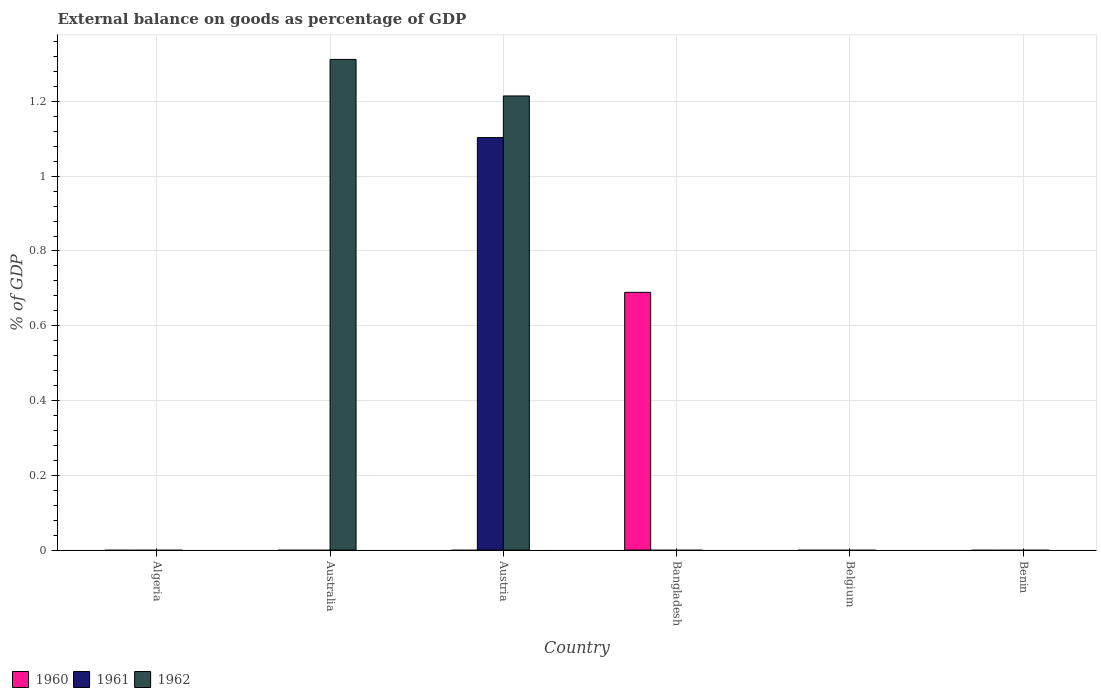Are the number of bars per tick equal to the number of legend labels?
Ensure brevity in your answer.  No. How many bars are there on the 6th tick from the right?
Offer a terse response. 0. What is the label of the 6th group of bars from the left?
Offer a terse response. Benin. Across all countries, what is the maximum external balance on goods as percentage of GDP in 1962?
Give a very brief answer. 1.31. Across all countries, what is the minimum external balance on goods as percentage of GDP in 1962?
Your response must be concise. 0. What is the total external balance on goods as percentage of GDP in 1962 in the graph?
Keep it short and to the point. 2.53. What is the difference between the external balance on goods as percentage of GDP in 1961 in Algeria and the external balance on goods as percentage of GDP in 1960 in Bangladesh?
Give a very brief answer. -0.69. What is the average external balance on goods as percentage of GDP in 1960 per country?
Provide a succinct answer. 0.11. In how many countries, is the external balance on goods as percentage of GDP in 1960 greater than 0.12 %?
Your answer should be very brief. 1. What is the difference between the highest and the lowest external balance on goods as percentage of GDP in 1960?
Offer a terse response. 0.69. Is it the case that in every country, the sum of the external balance on goods as percentage of GDP in 1960 and external balance on goods as percentage of GDP in 1962 is greater than the external balance on goods as percentage of GDP in 1961?
Offer a very short reply. No. Are all the bars in the graph horizontal?
Your response must be concise. No. How many countries are there in the graph?
Provide a succinct answer. 6. Does the graph contain grids?
Your answer should be very brief. Yes. How many legend labels are there?
Provide a short and direct response. 3. What is the title of the graph?
Make the answer very short. External balance on goods as percentage of GDP. Does "1962" appear as one of the legend labels in the graph?
Provide a short and direct response. Yes. What is the label or title of the Y-axis?
Offer a terse response. % of GDP. What is the % of GDP in 1962 in Algeria?
Ensure brevity in your answer.  0. What is the % of GDP of 1961 in Australia?
Offer a terse response. 0. What is the % of GDP of 1962 in Australia?
Your response must be concise. 1.31. What is the % of GDP in 1961 in Austria?
Your answer should be compact. 1.1. What is the % of GDP in 1962 in Austria?
Make the answer very short. 1.21. What is the % of GDP in 1960 in Bangladesh?
Your answer should be compact. 0.69. What is the % of GDP of 1960 in Belgium?
Keep it short and to the point. 0. What is the % of GDP of 1961 in Belgium?
Your answer should be compact. 0. What is the % of GDP in 1962 in Belgium?
Keep it short and to the point. 0. What is the % of GDP of 1960 in Benin?
Your answer should be compact. 0. Across all countries, what is the maximum % of GDP of 1960?
Make the answer very short. 0.69. Across all countries, what is the maximum % of GDP of 1961?
Offer a terse response. 1.1. Across all countries, what is the maximum % of GDP in 1962?
Provide a short and direct response. 1.31. Across all countries, what is the minimum % of GDP in 1961?
Provide a short and direct response. 0. Across all countries, what is the minimum % of GDP of 1962?
Your answer should be very brief. 0. What is the total % of GDP of 1960 in the graph?
Provide a succinct answer. 0.69. What is the total % of GDP of 1961 in the graph?
Your response must be concise. 1.1. What is the total % of GDP of 1962 in the graph?
Keep it short and to the point. 2.53. What is the difference between the % of GDP of 1962 in Australia and that in Austria?
Ensure brevity in your answer.  0.1. What is the average % of GDP in 1960 per country?
Ensure brevity in your answer.  0.11. What is the average % of GDP of 1961 per country?
Offer a very short reply. 0.18. What is the average % of GDP in 1962 per country?
Give a very brief answer. 0.42. What is the difference between the % of GDP of 1961 and % of GDP of 1962 in Austria?
Make the answer very short. -0.11. What is the ratio of the % of GDP in 1962 in Australia to that in Austria?
Offer a very short reply. 1.08. What is the difference between the highest and the lowest % of GDP of 1960?
Your answer should be compact. 0.69. What is the difference between the highest and the lowest % of GDP of 1961?
Your answer should be compact. 1.1. What is the difference between the highest and the lowest % of GDP in 1962?
Offer a very short reply. 1.31. 